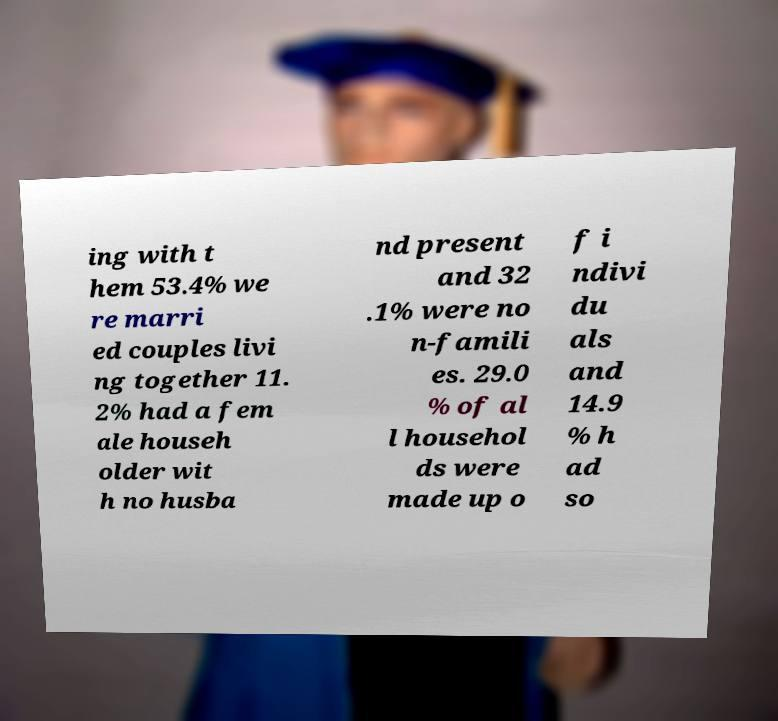Can you read and provide the text displayed in the image?This photo seems to have some interesting text. Can you extract and type it out for me? ing with t hem 53.4% we re marri ed couples livi ng together 11. 2% had a fem ale househ older wit h no husba nd present and 32 .1% were no n-famili es. 29.0 % of al l househol ds were made up o f i ndivi du als and 14.9 % h ad so 